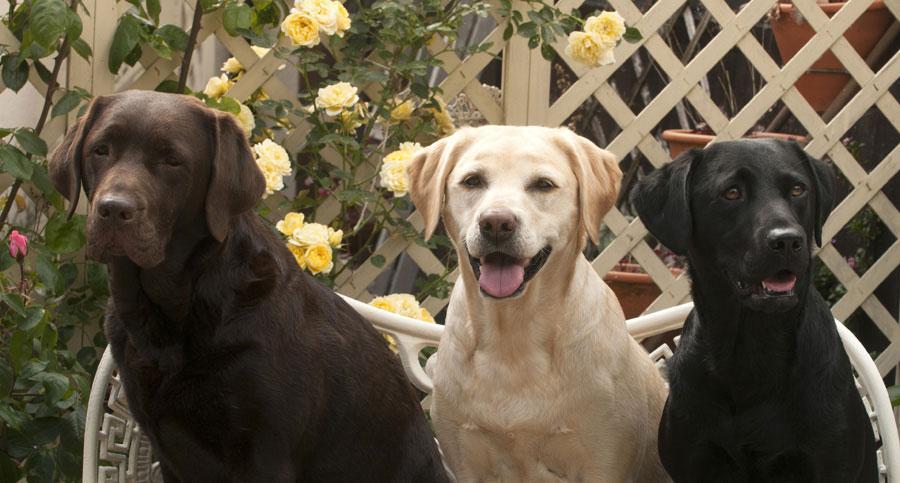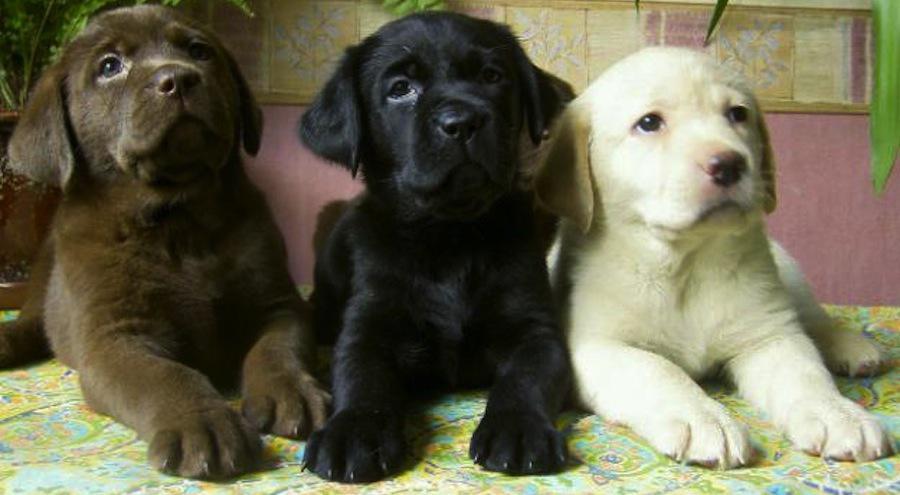The first image is the image on the left, the second image is the image on the right. Examine the images to the left and right. Is the description "The right image contains three dogs seated outside." accurate? Answer yes or no. No. The first image is the image on the left, the second image is the image on the right. Analyze the images presented: Is the assertion "An image shows three different solid color dogs posed side-by-side, with the black dog in the middle." valid? Answer yes or no. Yes. 